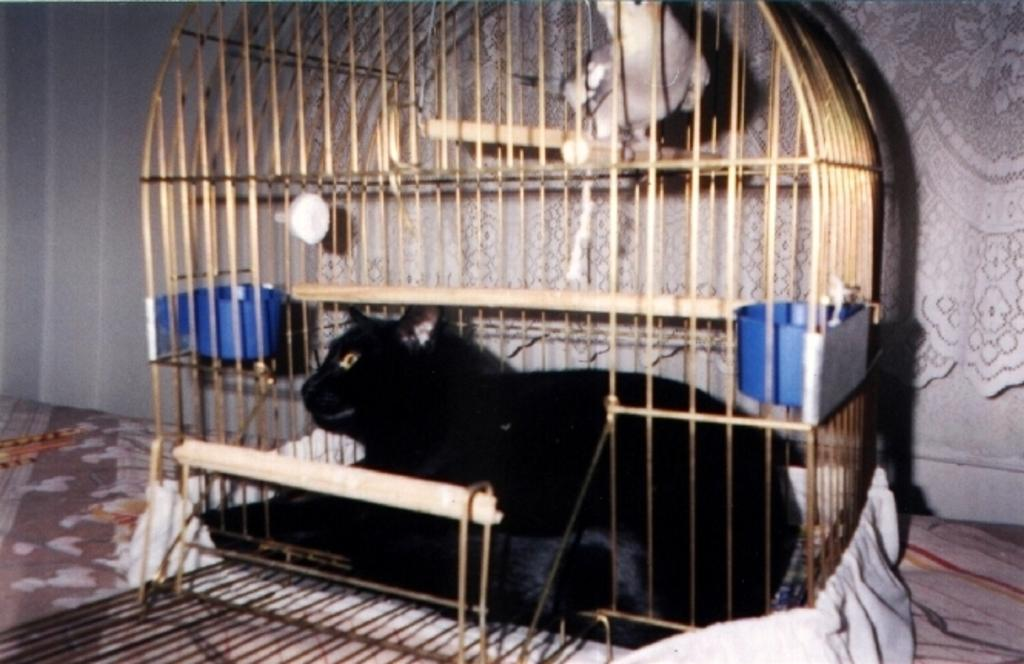What type of animal is in the cage in the image? There is a black cat in a cage in the image. What other animal can be seen in the image? There is a parrot at the top of the cage in the image. What language is the hospital using to communicate with the drain in the image? There is no hospital or drain present in the image; it features a black cat in a cage and a parrot at the top of the cage. 